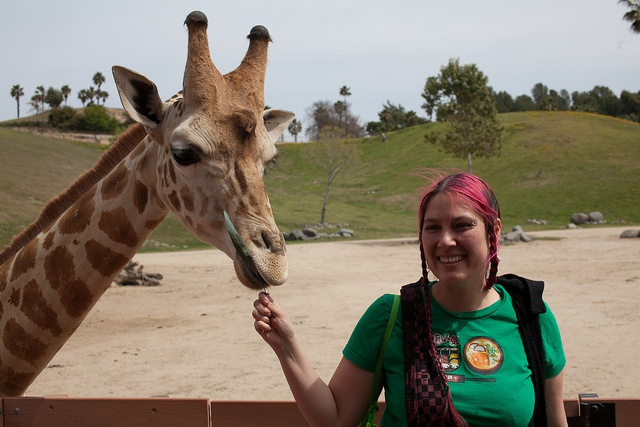Describe the objects in this image and their specific colors. I can see giraffe in lightgray, maroon, black, and gray tones, people in lightgray, black, maroon, teal, and brown tones, handbag in lightgray, black, maroon, and brown tones, handbag in lightgray, black, darkgreen, and maroon tones, and giraffe in lightgray, gray, black, and maroon tones in this image. 